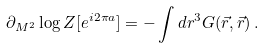<formula> <loc_0><loc_0><loc_500><loc_500>\partial _ { M ^ { 2 } } \log Z [ e ^ { i 2 \pi a } ] = - \int d r ^ { 3 } G ( \vec { r } , \vec { r } ) \, .</formula> 